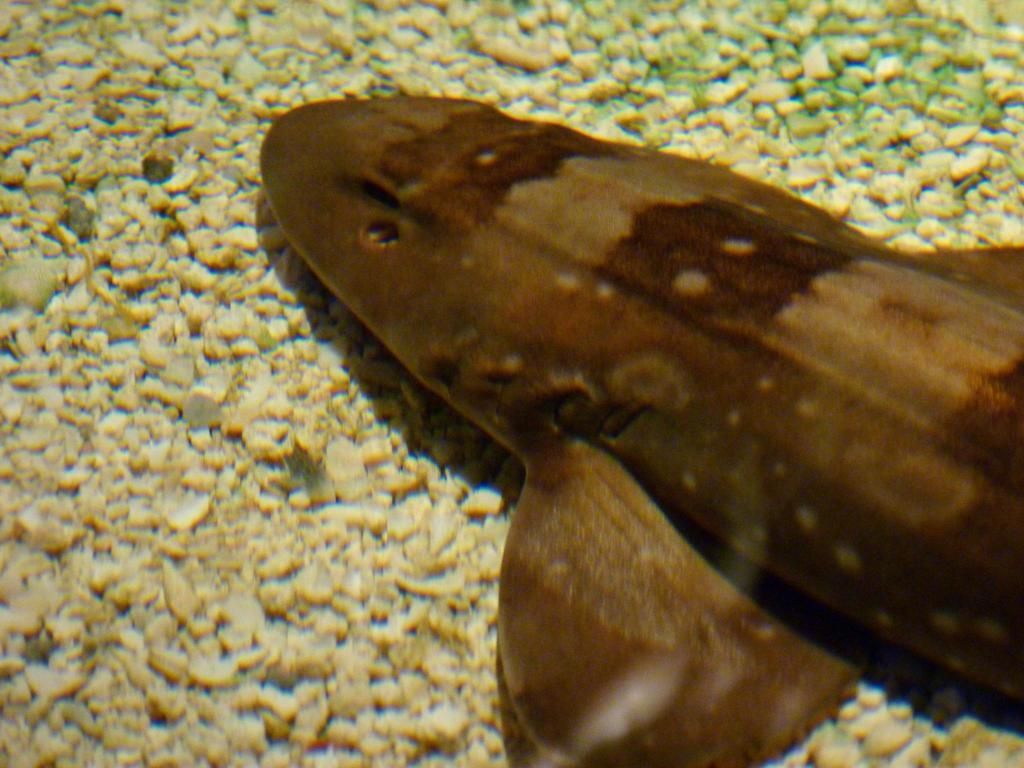What type of animal is present in the image? There is a fish in the image. What else can be seen in the image besides the fish? There are stones in the image. What type of drink is being served in the frame of the image? There is no drink or frame present in the image; it only features a fish and stones. 